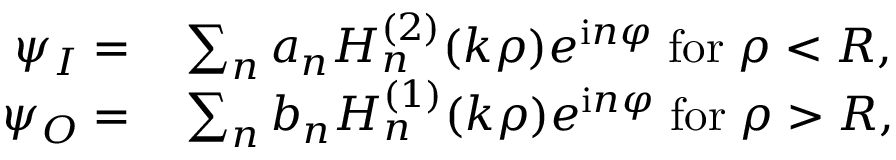<formula> <loc_0><loc_0><loc_500><loc_500>\begin{array} { r l } { \psi _ { I } = } & \sum _ { n } a _ { n } H _ { n } ^ { ( 2 ) } ( k \rho ) e ^ { i n \varphi } \, f o r \, \rho < R , } \\ { \psi _ { O } = } & \sum _ { n } b _ { n } H _ { n } ^ { ( 1 ) } ( k \rho ) e ^ { i n \varphi } \, f o r \, \rho > R , } \end{array}</formula> 